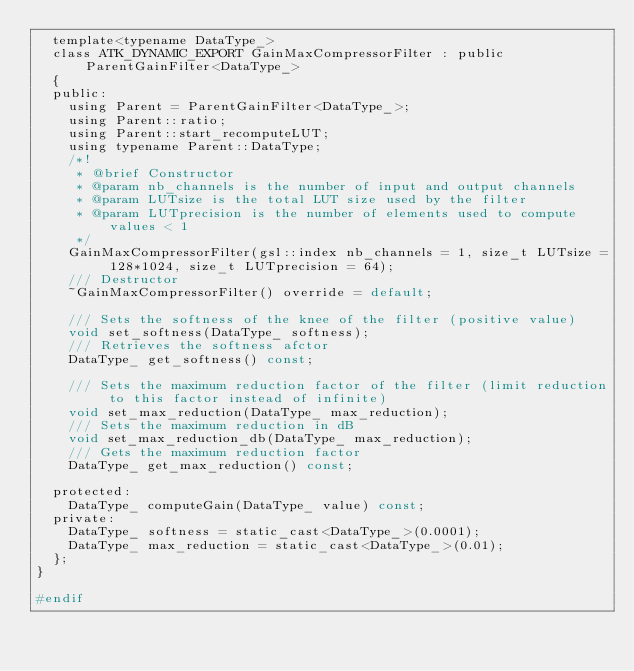<code> <loc_0><loc_0><loc_500><loc_500><_C_>  template<typename DataType_>
  class ATK_DYNAMIC_EXPORT GainMaxCompressorFilter : public ParentGainFilter<DataType_>
  {
  public:
    using Parent = ParentGainFilter<DataType_>;
    using Parent::ratio;
    using Parent::start_recomputeLUT;
    using typename Parent::DataType;
    /*!
     * @brief Constructor
     * @param nb_channels is the number of input and output channels
     * @param LUTsize is the total LUT size used by the filter
     * @param LUTprecision is the number of elements used to compute values < 1
     */
    GainMaxCompressorFilter(gsl::index nb_channels = 1, size_t LUTsize = 128*1024, size_t LUTprecision = 64);
    /// Destructor
    ~GainMaxCompressorFilter() override = default;

    /// Sets the softness of the knee of the filter (positive value)
    void set_softness(DataType_ softness);
    /// Retrieves the softness afctor
    DataType_ get_softness() const;

    /// Sets the maximum reduction factor of the filter (limit reduction to this factor instead of infinite)
    void set_max_reduction(DataType_ max_reduction);
    /// Sets the maximum reduction in dB
    void set_max_reduction_db(DataType_ max_reduction);
    /// Gets the maximum reduction factor
    DataType_ get_max_reduction() const;

  protected:
    DataType_ computeGain(DataType_ value) const;
  private:
    DataType_ softness = static_cast<DataType_>(0.0001);
    DataType_ max_reduction = static_cast<DataType_>(0.01);
  };
}

#endif
</code> 